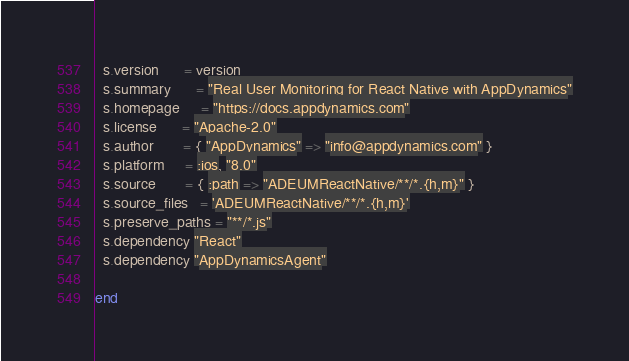<code> <loc_0><loc_0><loc_500><loc_500><_Ruby_>  s.version      = version
  s.summary      = "Real User Monitoring for React Native with AppDynamics"
  s.homepage     = "https://docs.appdynamics.com"
  s.license      = "Apache-2.0"
  s.author       = { "AppDynamics" => "info@appdynamics.com" }
  s.platform     = :ios, "8.0"
  s.source       = { :path => "ADEUMReactNative/**/*.{h,m}" }
  s.source_files   = 'ADEUMReactNative/**/*.{h,m}'
  s.preserve_paths = "**/*.js"
  s.dependency "React"
  s.dependency "AppDynamicsAgent"

end
</code> 